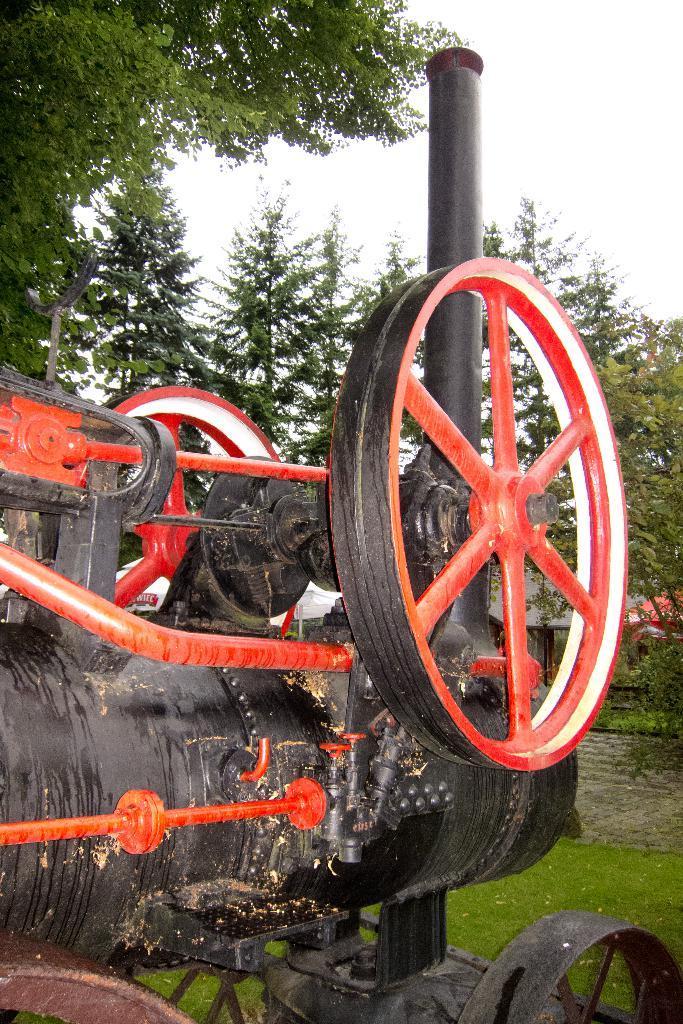In one or two sentences, can you explain what this image depicts? In the center of the image, we can see a vehicle and in the background, there are trees and there is a shed. At the bottom, there is ground. 